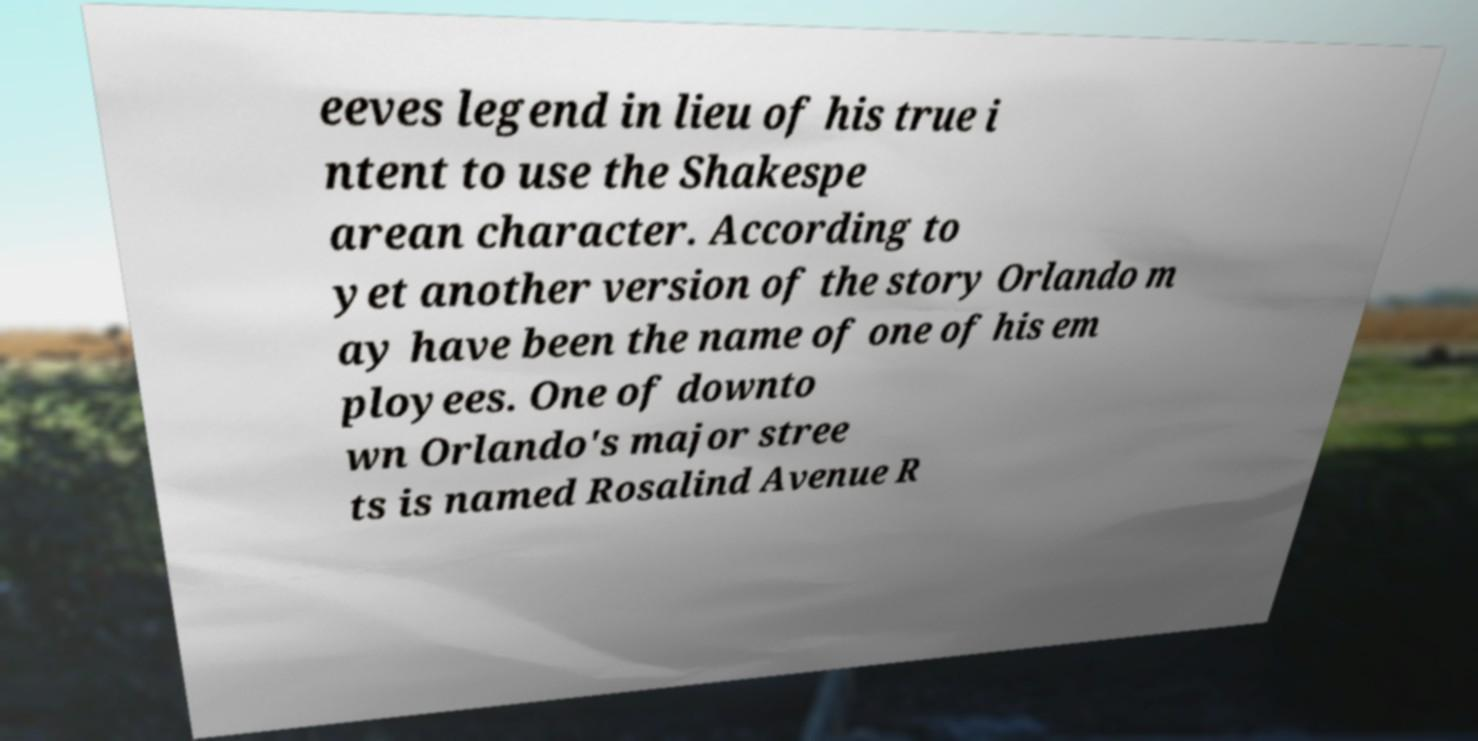I need the written content from this picture converted into text. Can you do that? eeves legend in lieu of his true i ntent to use the Shakespe arean character. According to yet another version of the story Orlando m ay have been the name of one of his em ployees. One of downto wn Orlando's major stree ts is named Rosalind Avenue R 